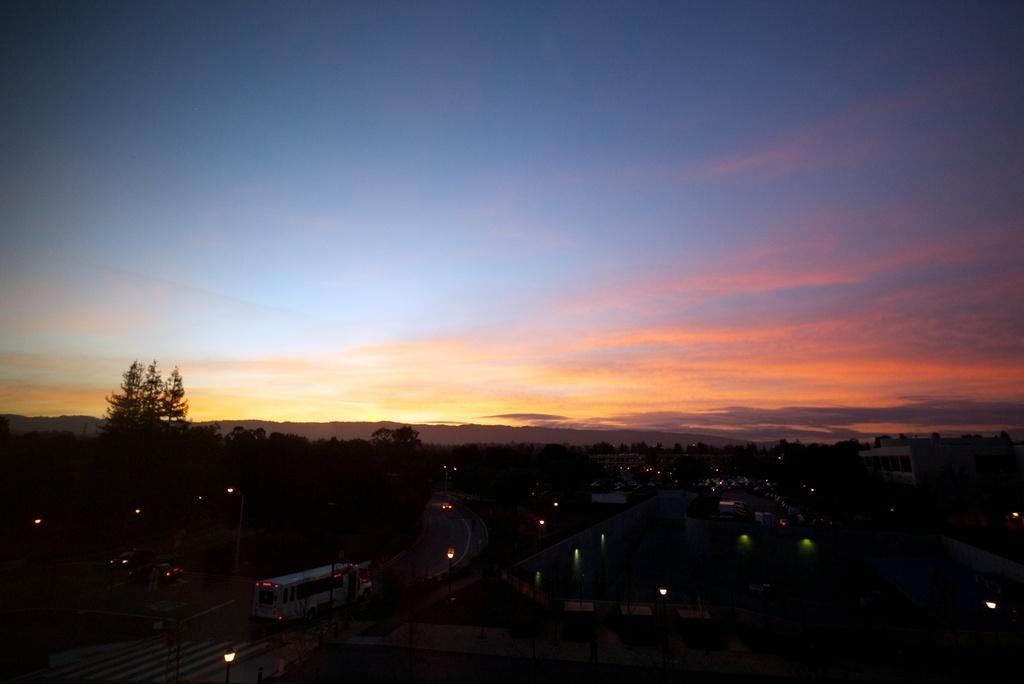What type of natural elements can be seen in the image? There are trees in the image. What type of man-made structures are present in the image? There are buildings in the image. What type of transportation is visible on the roads in the image? There are vehicles on the roads in the image. What type of illumination is visible in the image? There are lights visible in the image. How would you describe the sky in the image? The sky is blue and cloudy in the image. What type of growth can be seen in the field in the image? There is no field present in the image; it features trees, buildings, vehicles, lights, and a blue, cloudy sky. What type of payment is required to enter the image? There is no payment required to enter the image, as it is a photograph or illustration and not a physical location. 